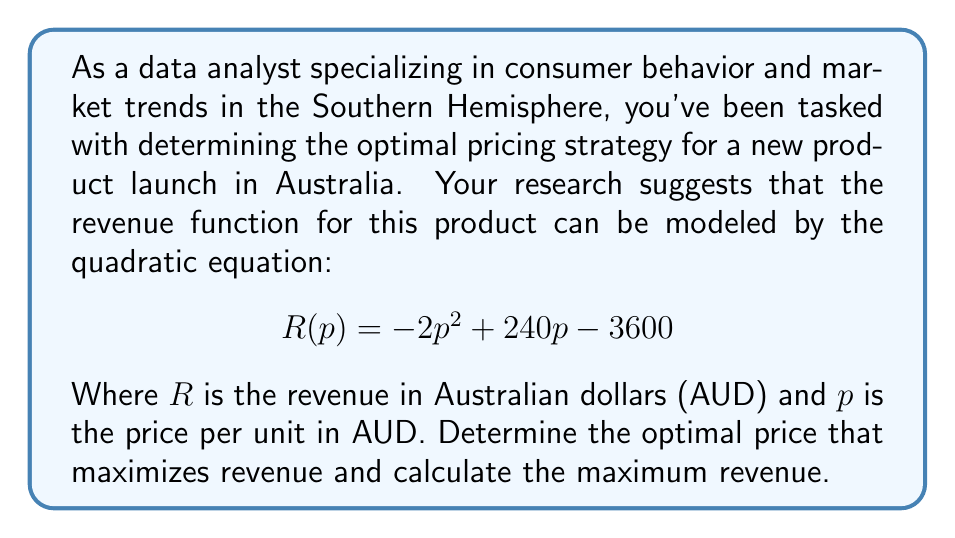Give your solution to this math problem. To solve this problem, we'll follow these steps:

1) The revenue function is a quadratic equation in the form of $R(p) = ap^2 + bp + c$, where $a = -2$, $b = 240$, and $c = -3600$.

2) To find the maximum revenue, we need to find the vertex of this parabola. The p-coordinate of the vertex will give us the optimal price.

3) For a quadratic function $f(x) = ax^2 + bx + c$, the x-coordinate of the vertex is given by $x = -\frac{b}{2a}$.

4) In our case, this translates to:

   $$p = -\frac{240}{2(-2)} = -\frac{240}{-4} = 60$$

5) Therefore, the optimal price is 60 AUD.

6) To find the maximum revenue, we substitute this price back into our original equation:

   $$R(60) = -2(60)^2 + 240(60) - 3600$$
   $$= -2(3600) + 14400 - 3600$$
   $$= -7200 + 14400 - 3600$$
   $$= 3600$$

7) Thus, the maximum revenue is 3600 AUD.

This solution aligns with economic theory: the parabola opens downward (because $a$ is negative), indicating that there's a "sweet spot" for pricing – set the price too low or too high, and revenue decreases.
Answer: The optimal price is 60 AUD, which yields a maximum revenue of 3600 AUD. 